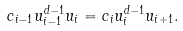<formula> <loc_0><loc_0><loc_500><loc_500>c _ { i - 1 } u _ { i - 1 } ^ { d - 1 } u _ { i } = c _ { i } u _ { i } ^ { d - 1 } u _ { i + 1 } .</formula> 